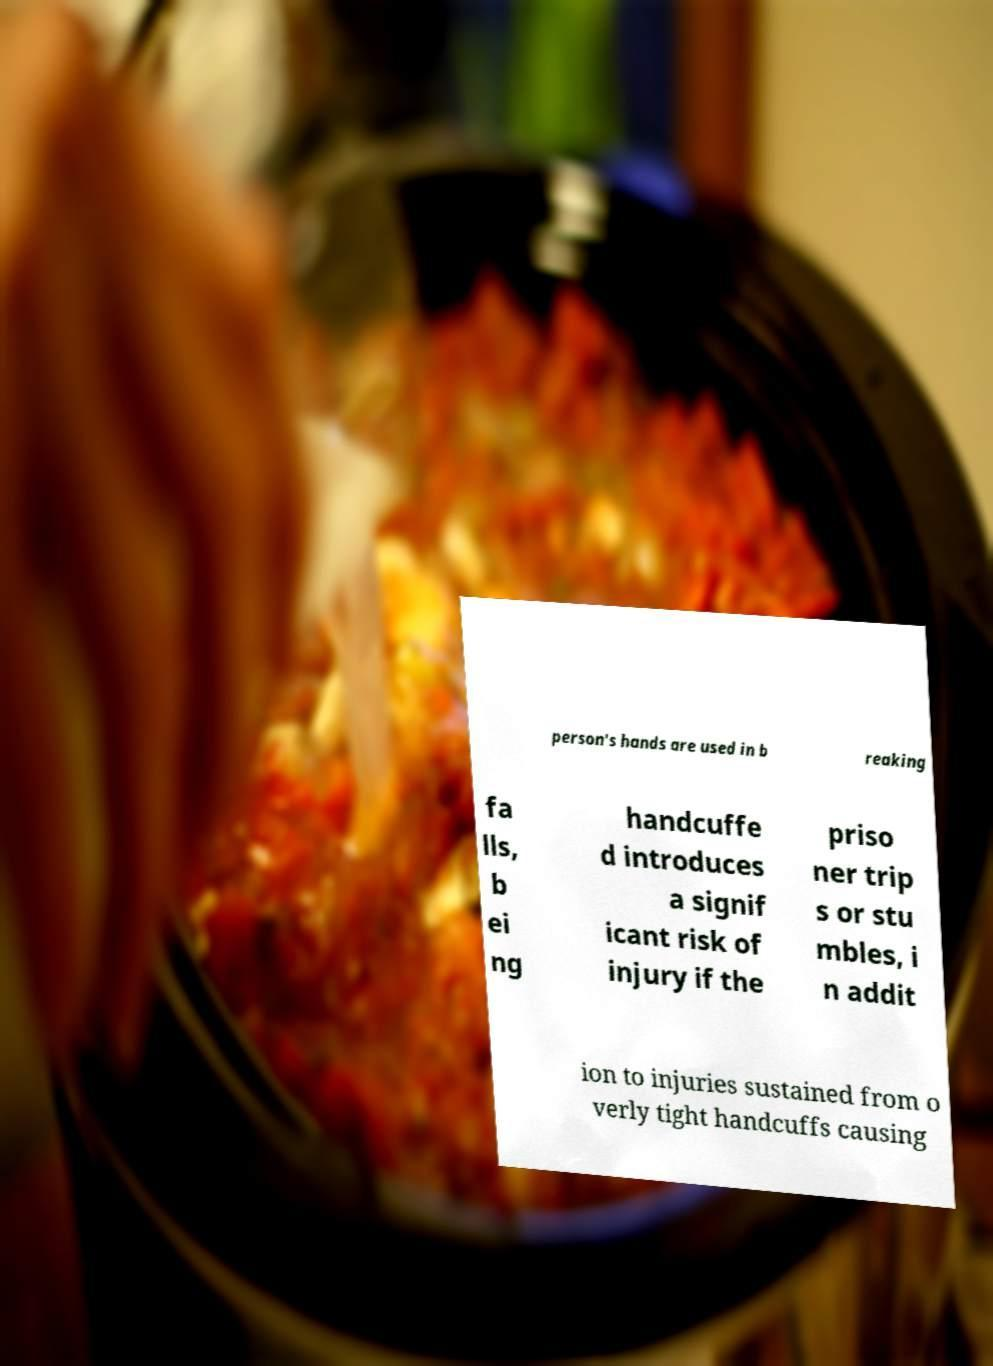I need the written content from this picture converted into text. Can you do that? person's hands are used in b reaking fa lls, b ei ng handcuffe d introduces a signif icant risk of injury if the priso ner trip s or stu mbles, i n addit ion to injuries sustained from o verly tight handcuffs causing 